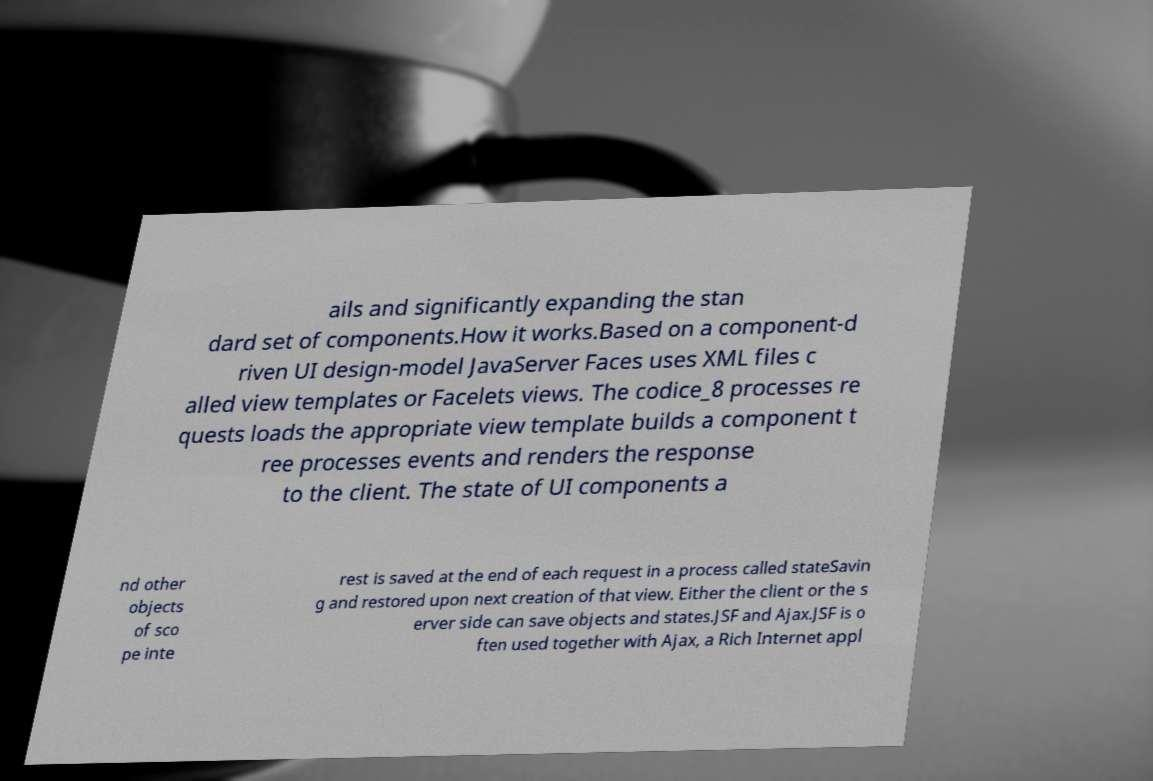What messages or text are displayed in this image? I need them in a readable, typed format. ails and significantly expanding the stan dard set of components.How it works.Based on a component-d riven UI design-model JavaServer Faces uses XML files c alled view templates or Facelets views. The codice_8 processes re quests loads the appropriate view template builds a component t ree processes events and renders the response to the client. The state of UI components a nd other objects of sco pe inte rest is saved at the end of each request in a process called stateSavin g and restored upon next creation of that view. Either the client or the s erver side can save objects and states.JSF and Ajax.JSF is o ften used together with Ajax, a Rich Internet appl 